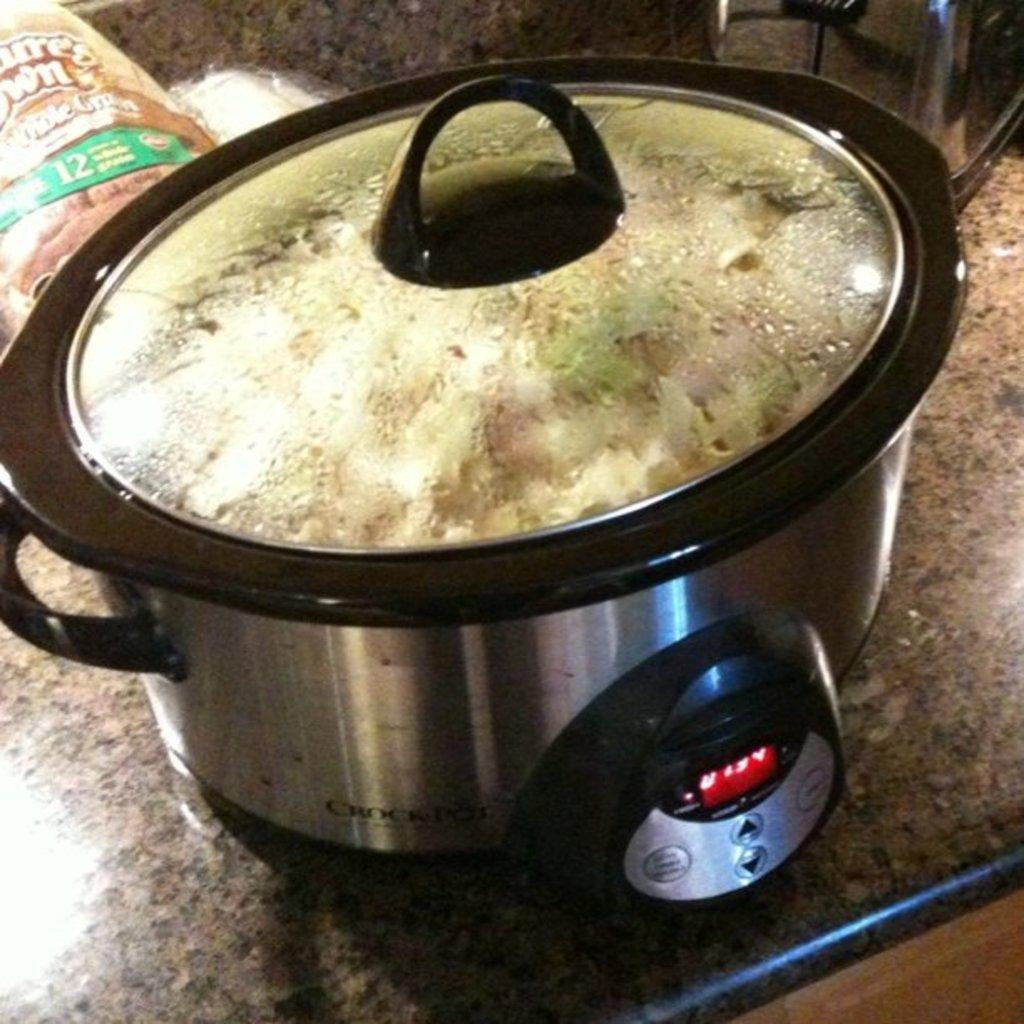What type of surface is shown in the image? The image shows the countertop of a kitchen. What appliance is present on the countertop? There is an electric cooker on the countertop. What colors can be seen on the electric cooker? The electric cooker is silver and black in color. What other objects can be seen on the countertop? There are other objects visible on the countertop. How does the minister compare to the park in the image? There is no minister or park present in the image; it only shows a kitchen countertop with an electric cooker and other objects. 